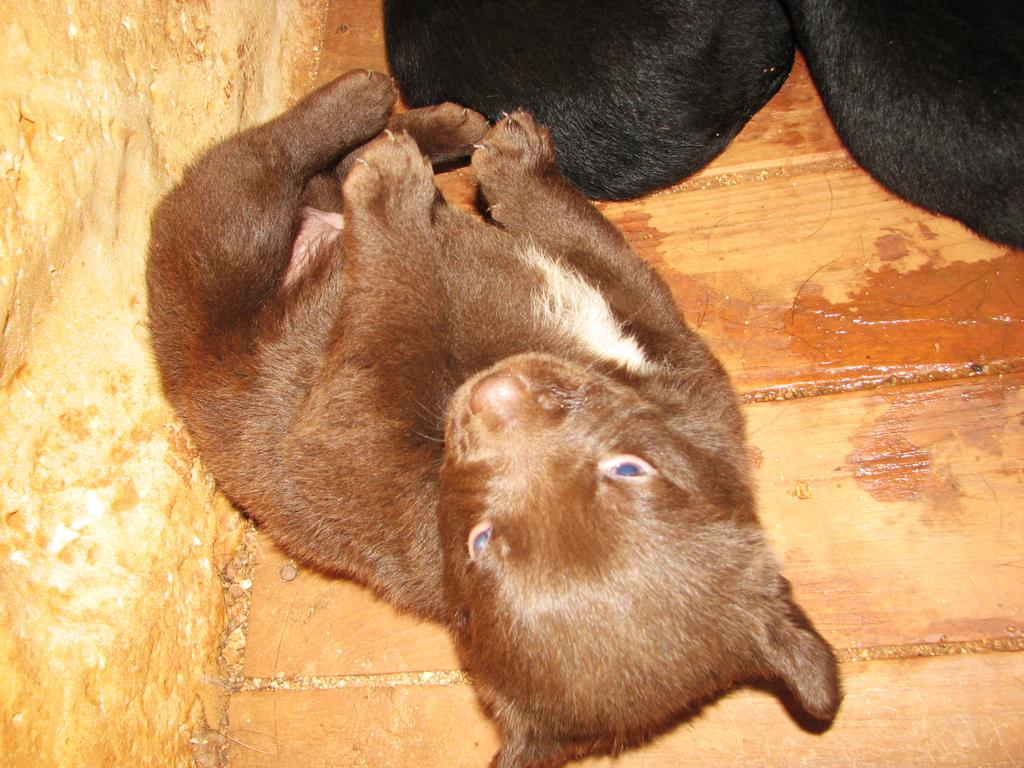What type of animal is in the image? There is a puppy in the image. What is the surface beneath the puppy? The puppy is on a wooden floor. Can you describe any other objects or features in the image? There is a black object or thing in the image. Where is the grandmother waiting for her flight in the image? There is no grandmother or airport present in the image; it features a puppy on a wooden floor. What type of needle is being used by the puppy in the image? There is no needle present in the image; it features a puppy on a wooden floor. 